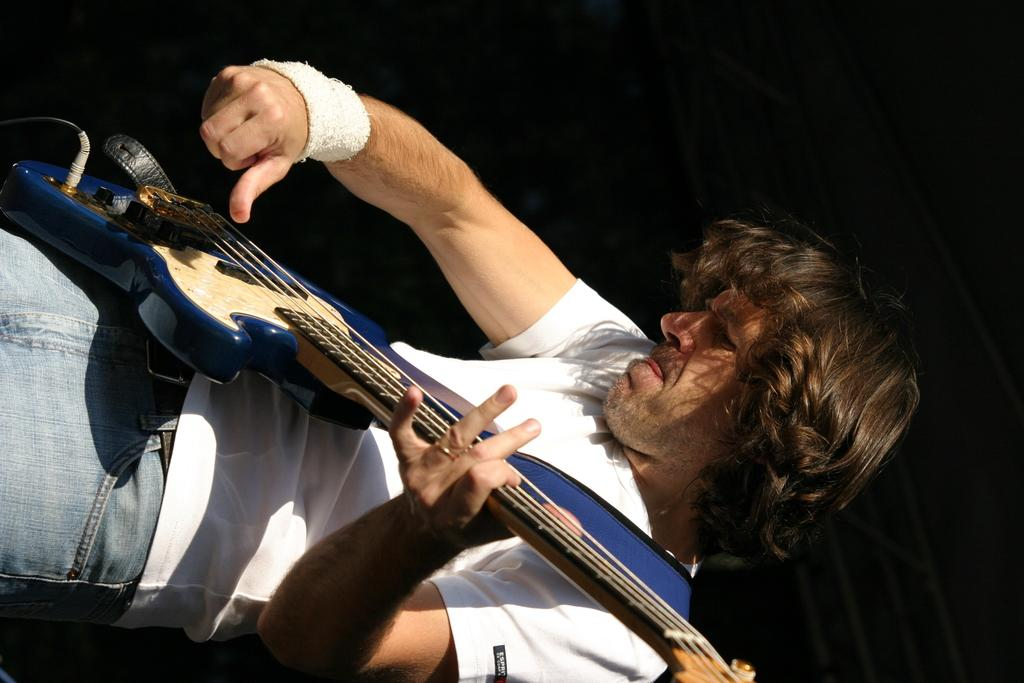What is the main subject of the image? There is a person in the image. What is the person wearing? The person is wearing a white t-shirt and blue jeans. What is the person doing in the image? The person is standing and holding a guitar. Can you describe the guitar? The guitar is blue and cream in color. What is the background of the image? The background of the image is black. Is there a woman standing next to the door in the image? There is no woman or door present in the image; it features a person holding a guitar against a black background. 